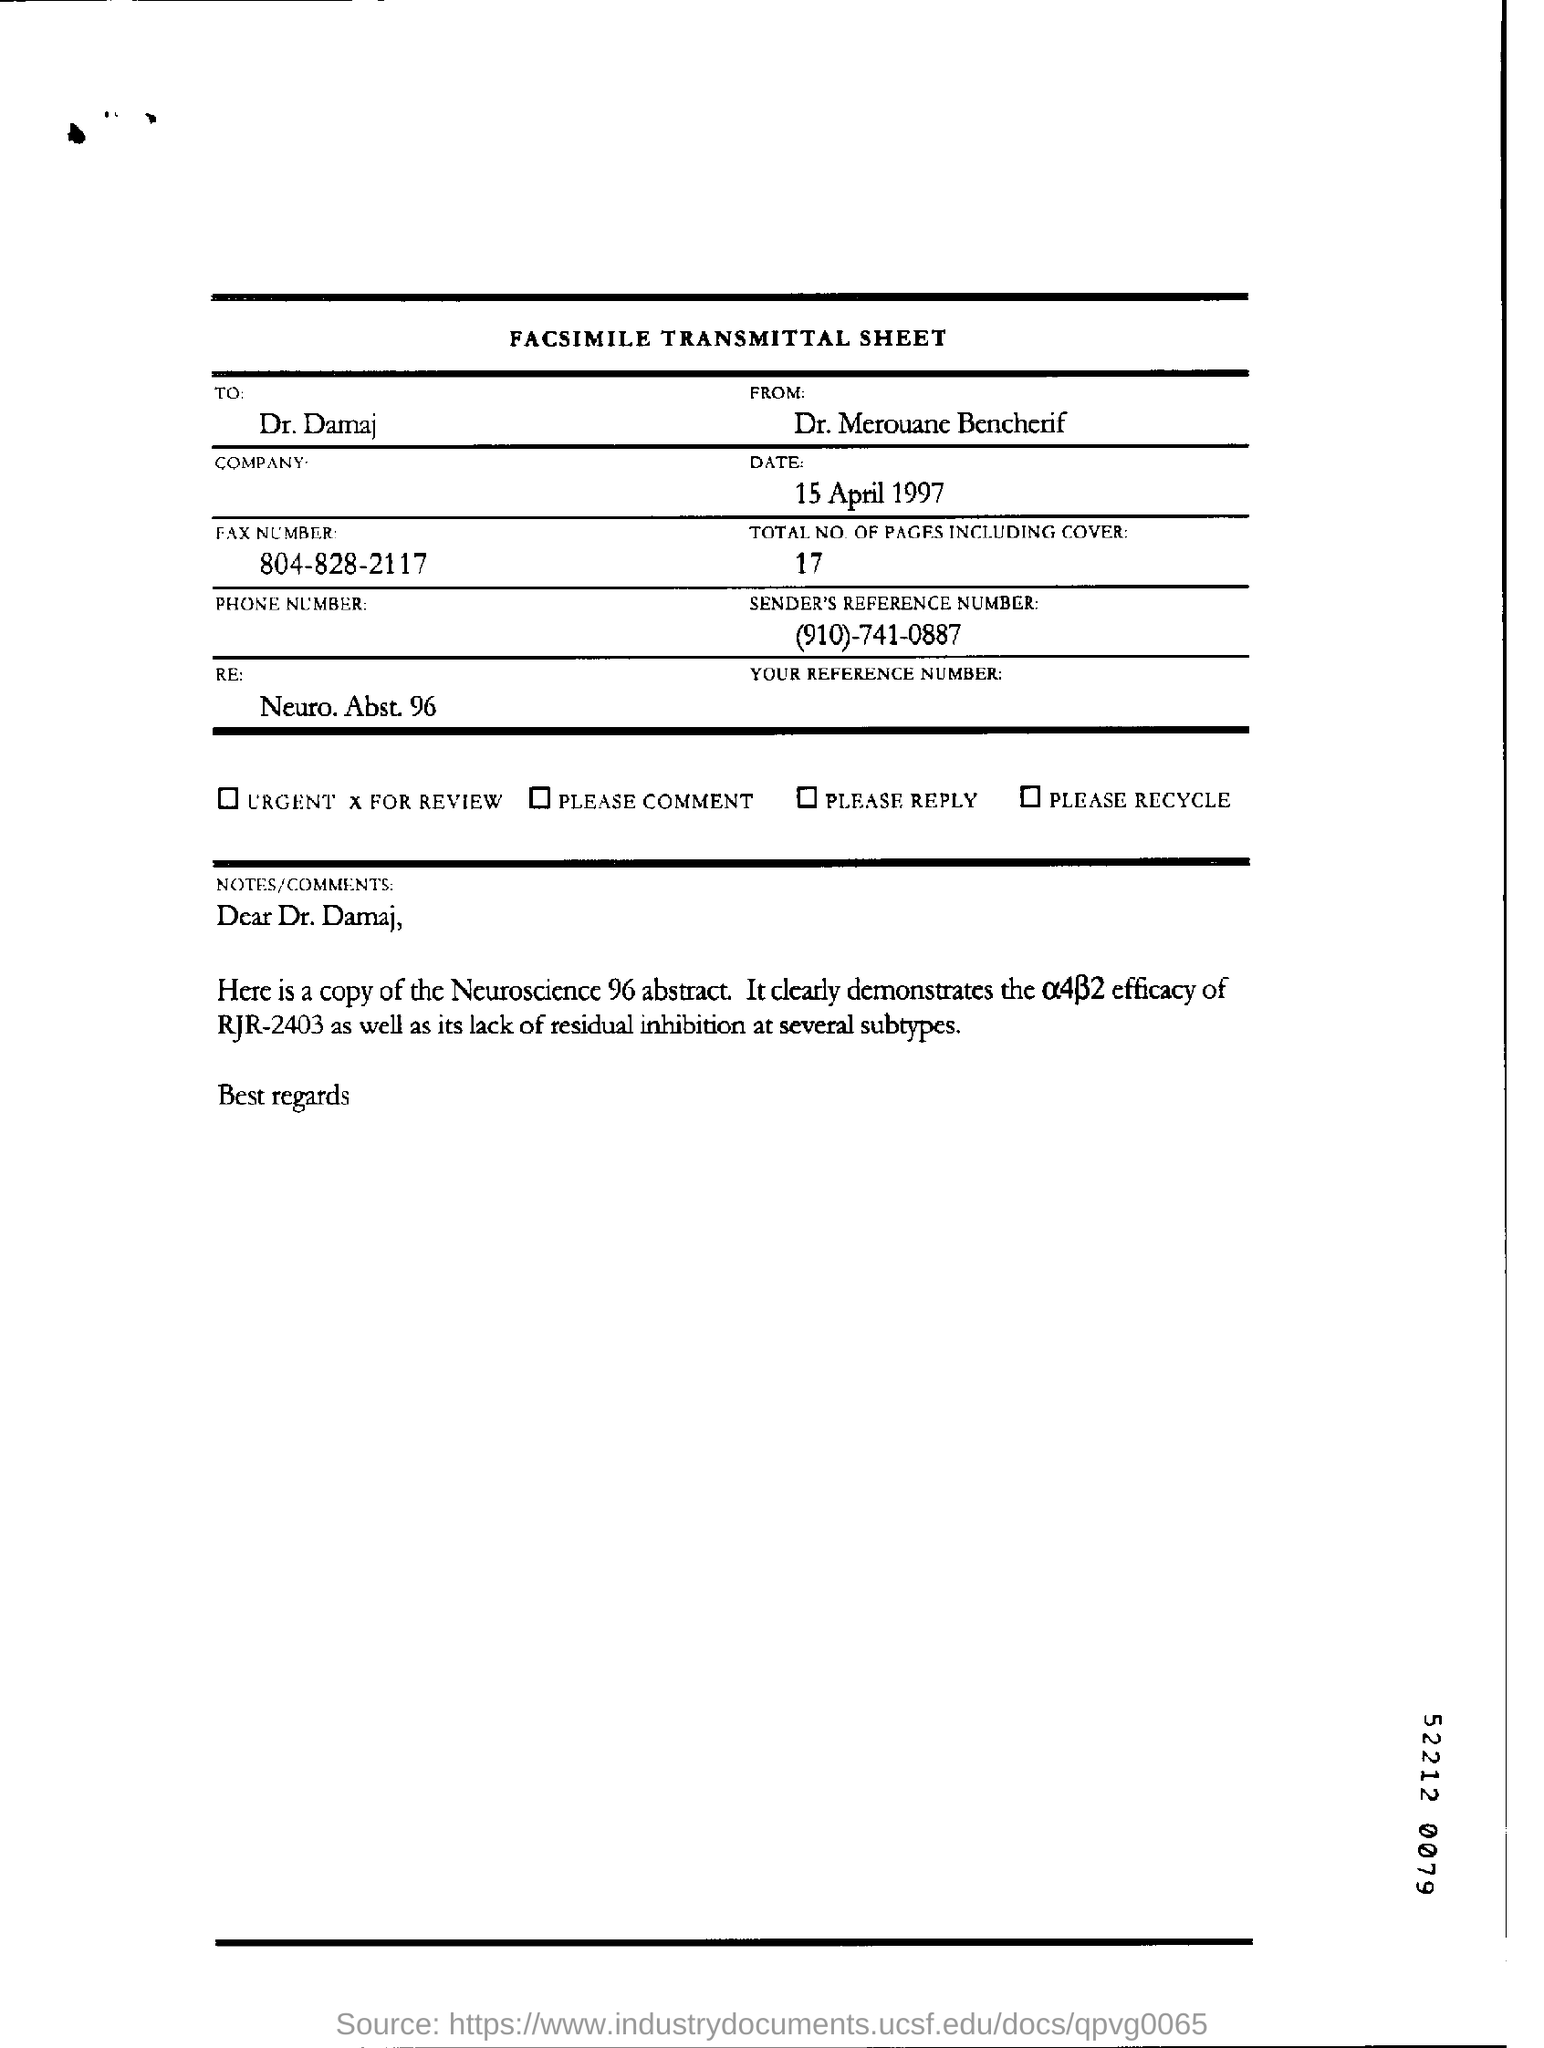What is the date of the document?
Provide a short and direct response. 15 April 1997. What is the total number of pages?
Your answer should be compact. 17. 